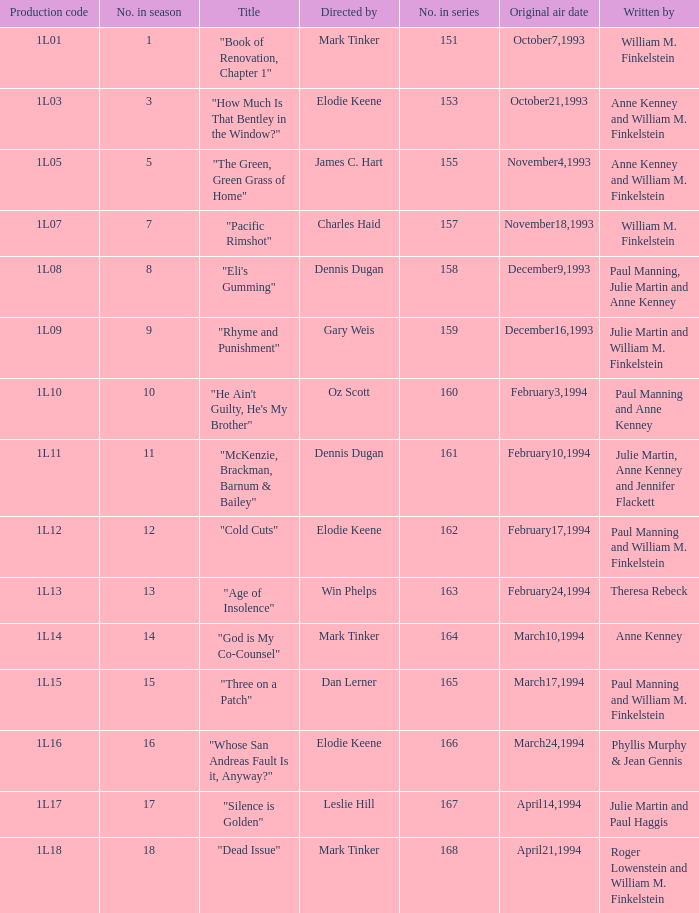Name who directed the production code 1l10 Oz Scott. 